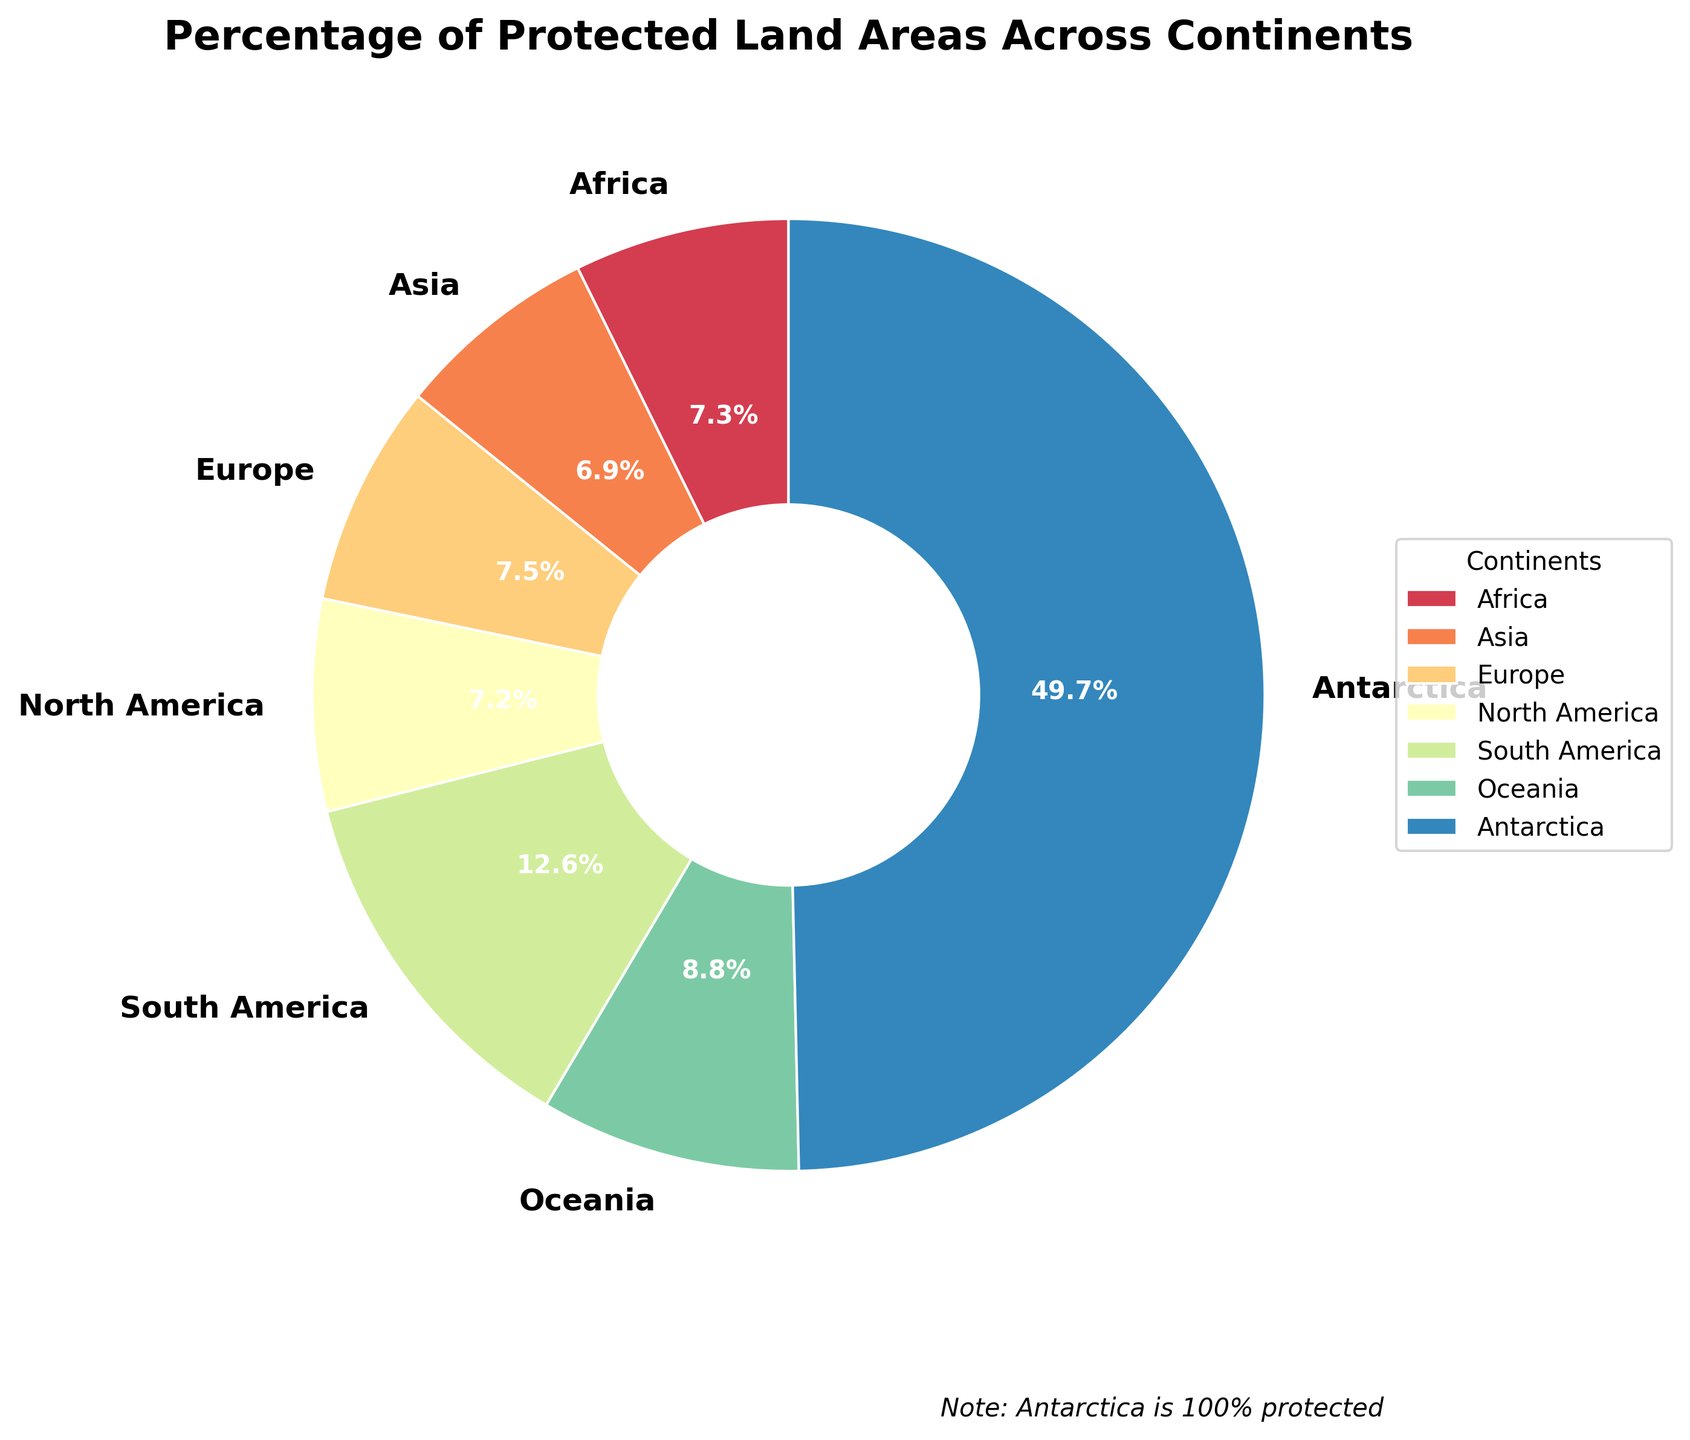What's the continent with the highest percentage of protected land areas? To find the highest percentage, we look at the slices of the pie chart. Antarctica has the largest section labeled 100%.
Answer: Antarctica Which continent has the lowest percentage of protected land areas? We need to look for the smallest slice in the pie chart. Asia has a 13.9% label, which is the smallest.
Answer: Asia What is the combined percentage of protected land areas for Africa and Europe? Add the percentages for Africa (14.7%) and Europe (15.2%). 14.7 + 15.2 = 29.9
Answer: 29.9% Which continents have more than 15% of their land protected? By examining the pie chart, we find that Europe (15.2%), South America (25.3%), and Oceania (17.8%) have more than 15% each.
Answer: Europe, South America, Oceania How does the percentage of protected land in Oceania compare to that in North America? From the pie chart, Oceania has 17.8% protected land, and North America has 14.5%. Oceania has a higher percentage than North America.
Answer: Oceania > North America What is the average percentage of protected land areas across Africa, Asia, and North America? Add the percentages for Africa (14.7%), Asia (13.9%), and North America (14.5%), then divide by 3. (14.7 + 13.9 + 14.5) / 3 = 14.37
Answer: 14.37% What is the difference in protected land percentage between South America and Asia? Subtract Asia's percentage from South America's percentage. 25.3 - 13.9 = 11.4
Answer: 11.4% Which continent's protected land percentage is closest to Africa's? Africa has 14.7%. By comparing the values, we see North America is closest with 14.5%.
Answer: North America What percentage of total protected land does Antarctica contribute if we consider all the listed continents? Since Antarctica's percentage is 100% protected, it is a special case. Excluding Antarctica, we compare the values against it.
Answer: Antarctica contributes 100% by itself How does South America's protected land percentage visually compare to the other continents? South America's slice is significantly larger, visually showing 25.3%, which is much more extensive compared to others except for Antarctica.
Answer: Larger than all others except Antarctica 